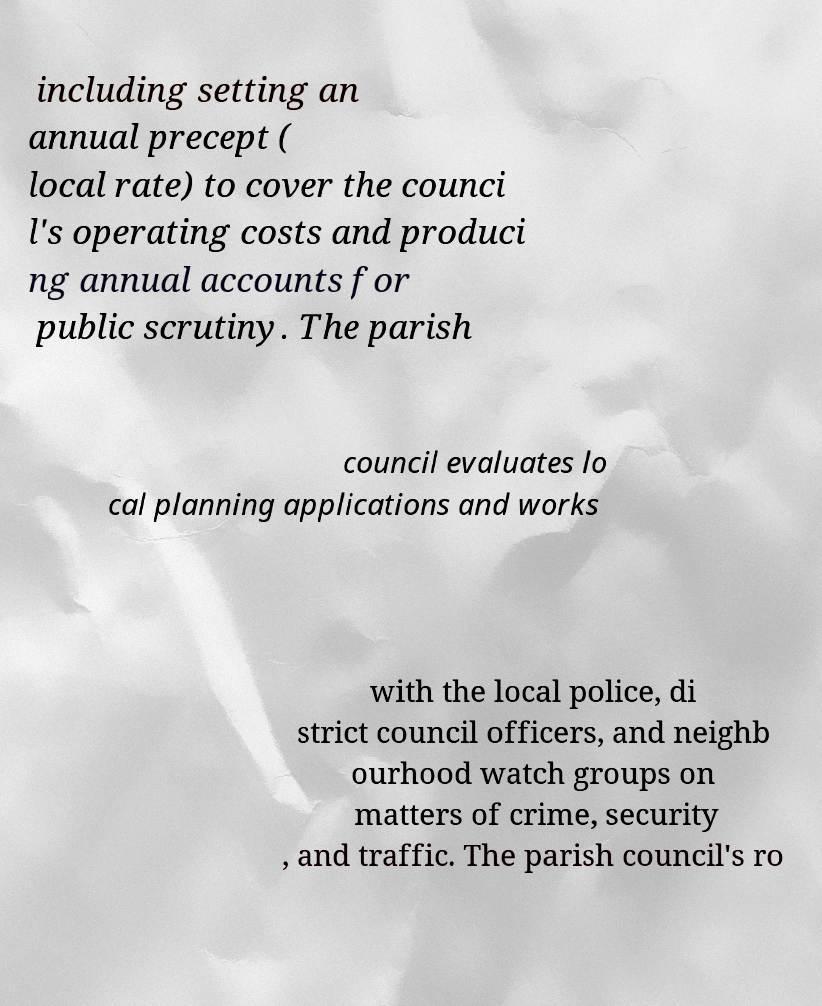There's text embedded in this image that I need extracted. Can you transcribe it verbatim? including setting an annual precept ( local rate) to cover the counci l's operating costs and produci ng annual accounts for public scrutiny. The parish council evaluates lo cal planning applications and works with the local police, di strict council officers, and neighb ourhood watch groups on matters of crime, security , and traffic. The parish council's ro 